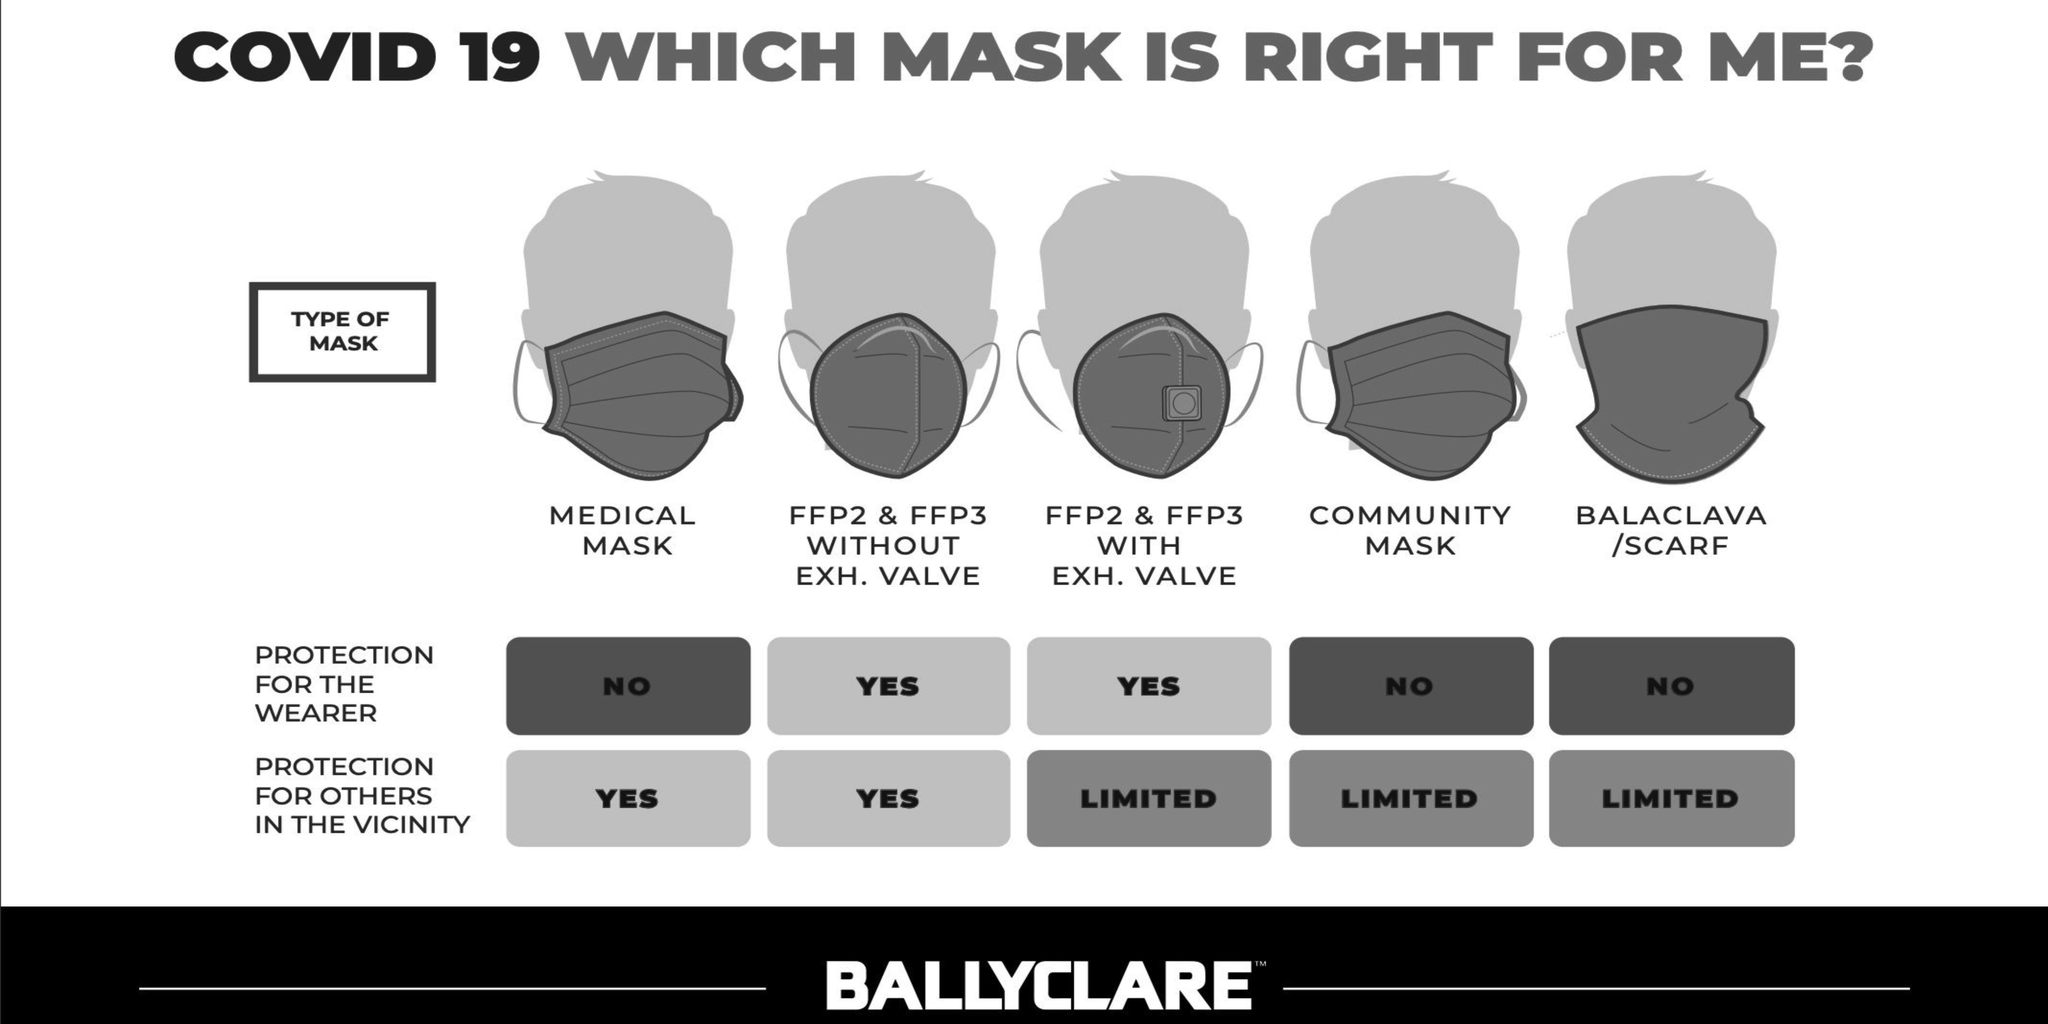Point out several critical features in this image. The FFP2 and FFP3 masks provide superior protection to both the wearer and those in the immediate vicinity, as they do not have an exhaust valve. The balaclava/scarf mask provides the same level of protection as a community mask against COVID-19 transmission, according to the World Health Organization. The medical mask provides inadequate protection to the wearer and effective protection to those around them. FFP2 and FFP3 masks provide excellent protection for the wearer while also offering limited protection for others due to their inclusion of an exhaust valve. 